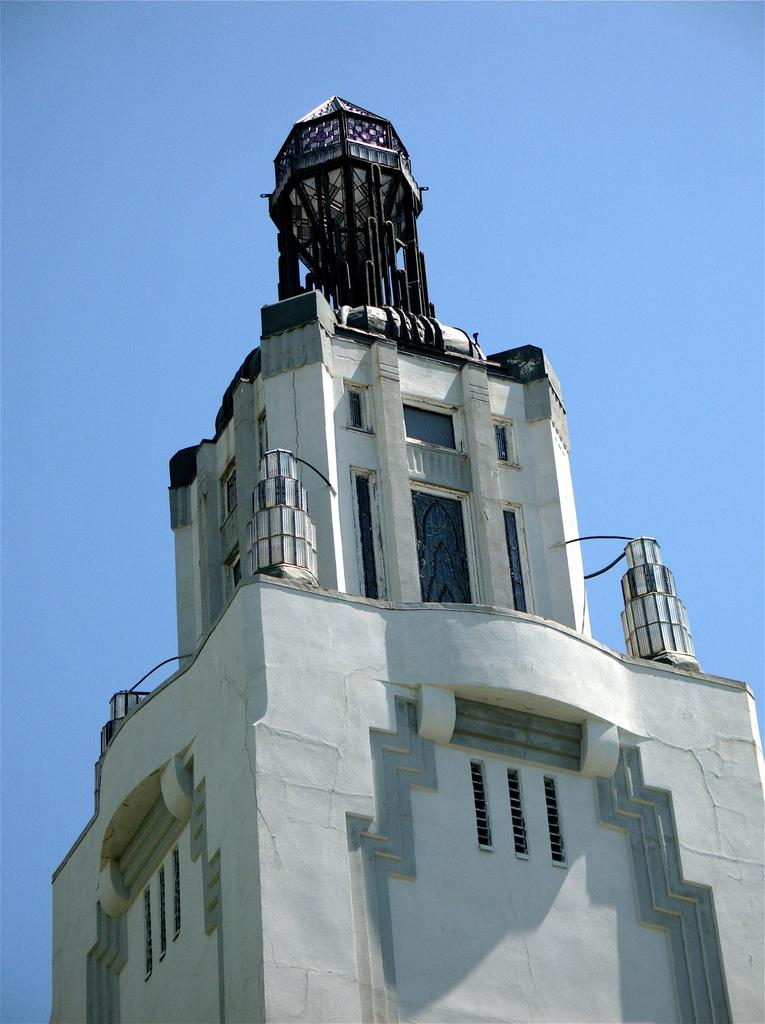What is the main subject of the picture? The main subject of the picture is a building. What specific features can be observed on the building? The building has windows. What is the condition of the sky in the picture? The sky is clear in the picture. What is the weather like in the image? It is sunny in the image. How many bears are visible on the roof of the building in the image? There are no bears present on the roof of the building in the image. What type of bubble can be seen floating near the building? There is no bubble present near the building in the image. 